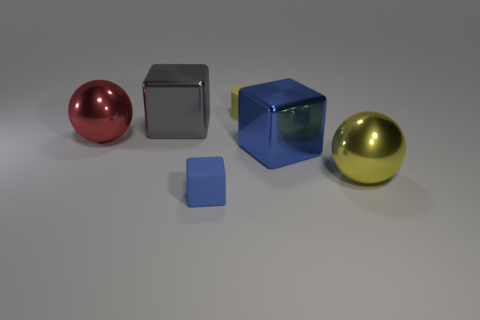Subtract all blue cubes. How many cubes are left? 1 Add 1 big yellow spheres. How many objects exist? 7 Subtract all gray blocks. How many blocks are left? 2 Subtract all spheres. How many objects are left? 4 Subtract all red balls. How many blue cubes are left? 2 Subtract all large blue objects. Subtract all blue objects. How many objects are left? 3 Add 4 big yellow spheres. How many big yellow spheres are left? 5 Add 4 big cyan blocks. How many big cyan blocks exist? 4 Subtract 2 blue blocks. How many objects are left? 4 Subtract all brown cylinders. Subtract all yellow balls. How many cylinders are left? 1 